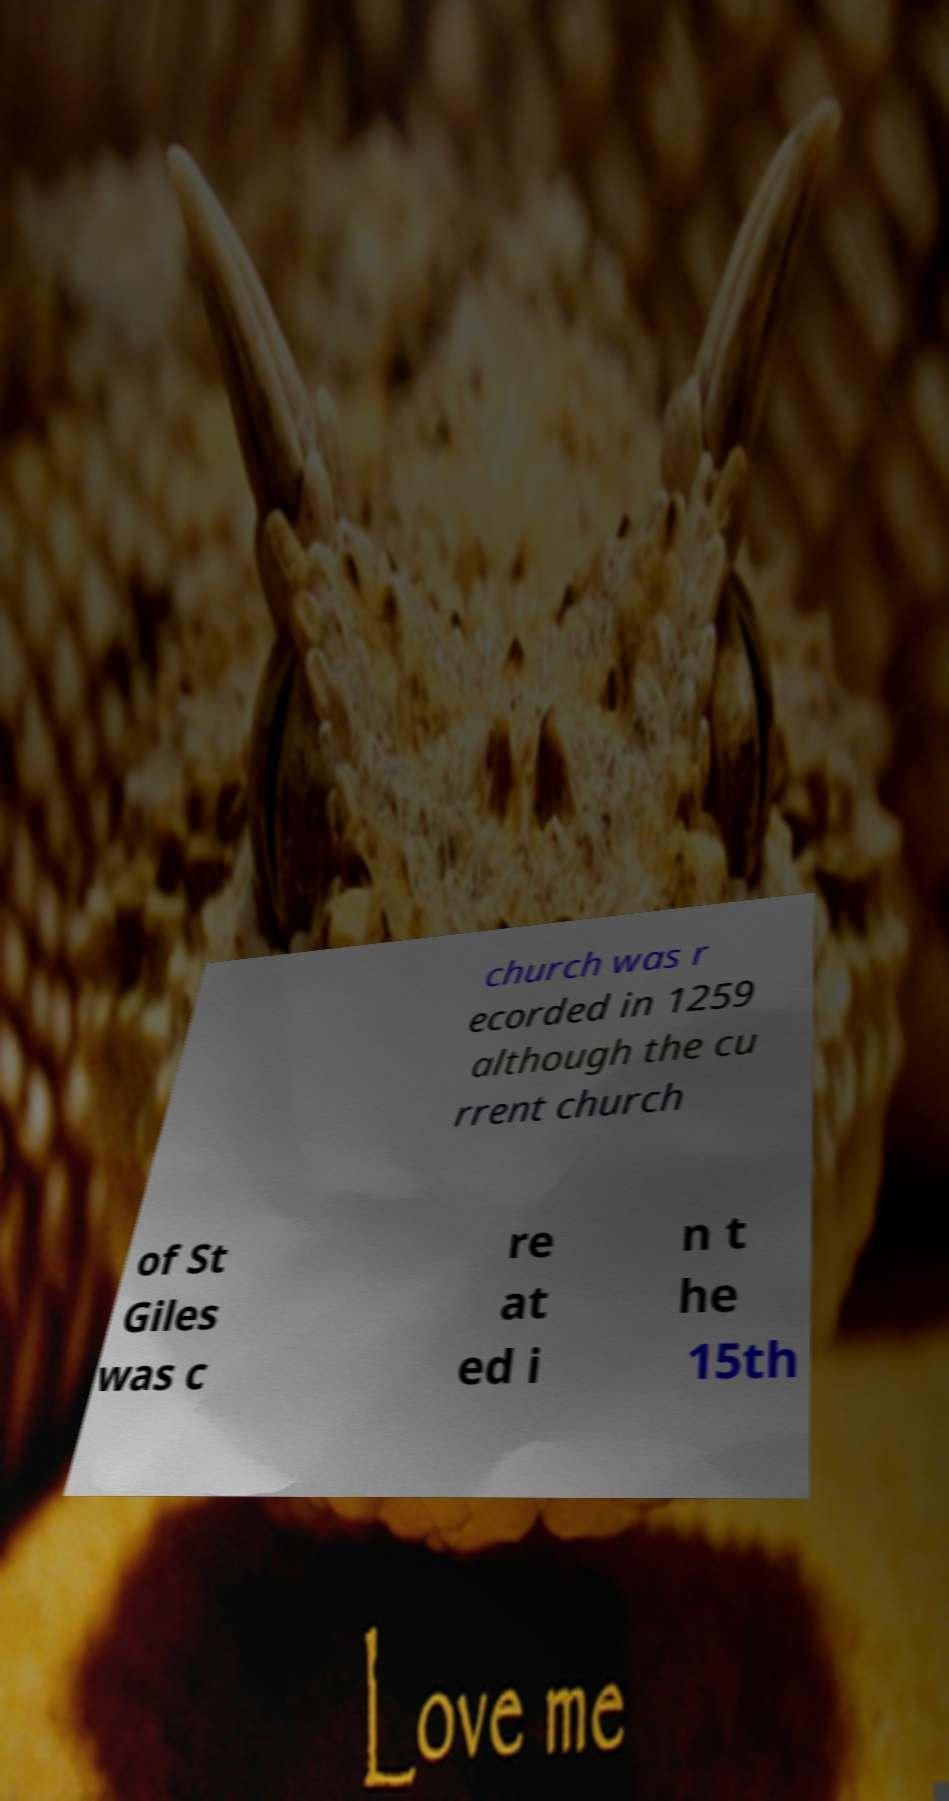Please read and relay the text visible in this image. What does it say? church was r ecorded in 1259 although the cu rrent church of St Giles was c re at ed i n t he 15th 